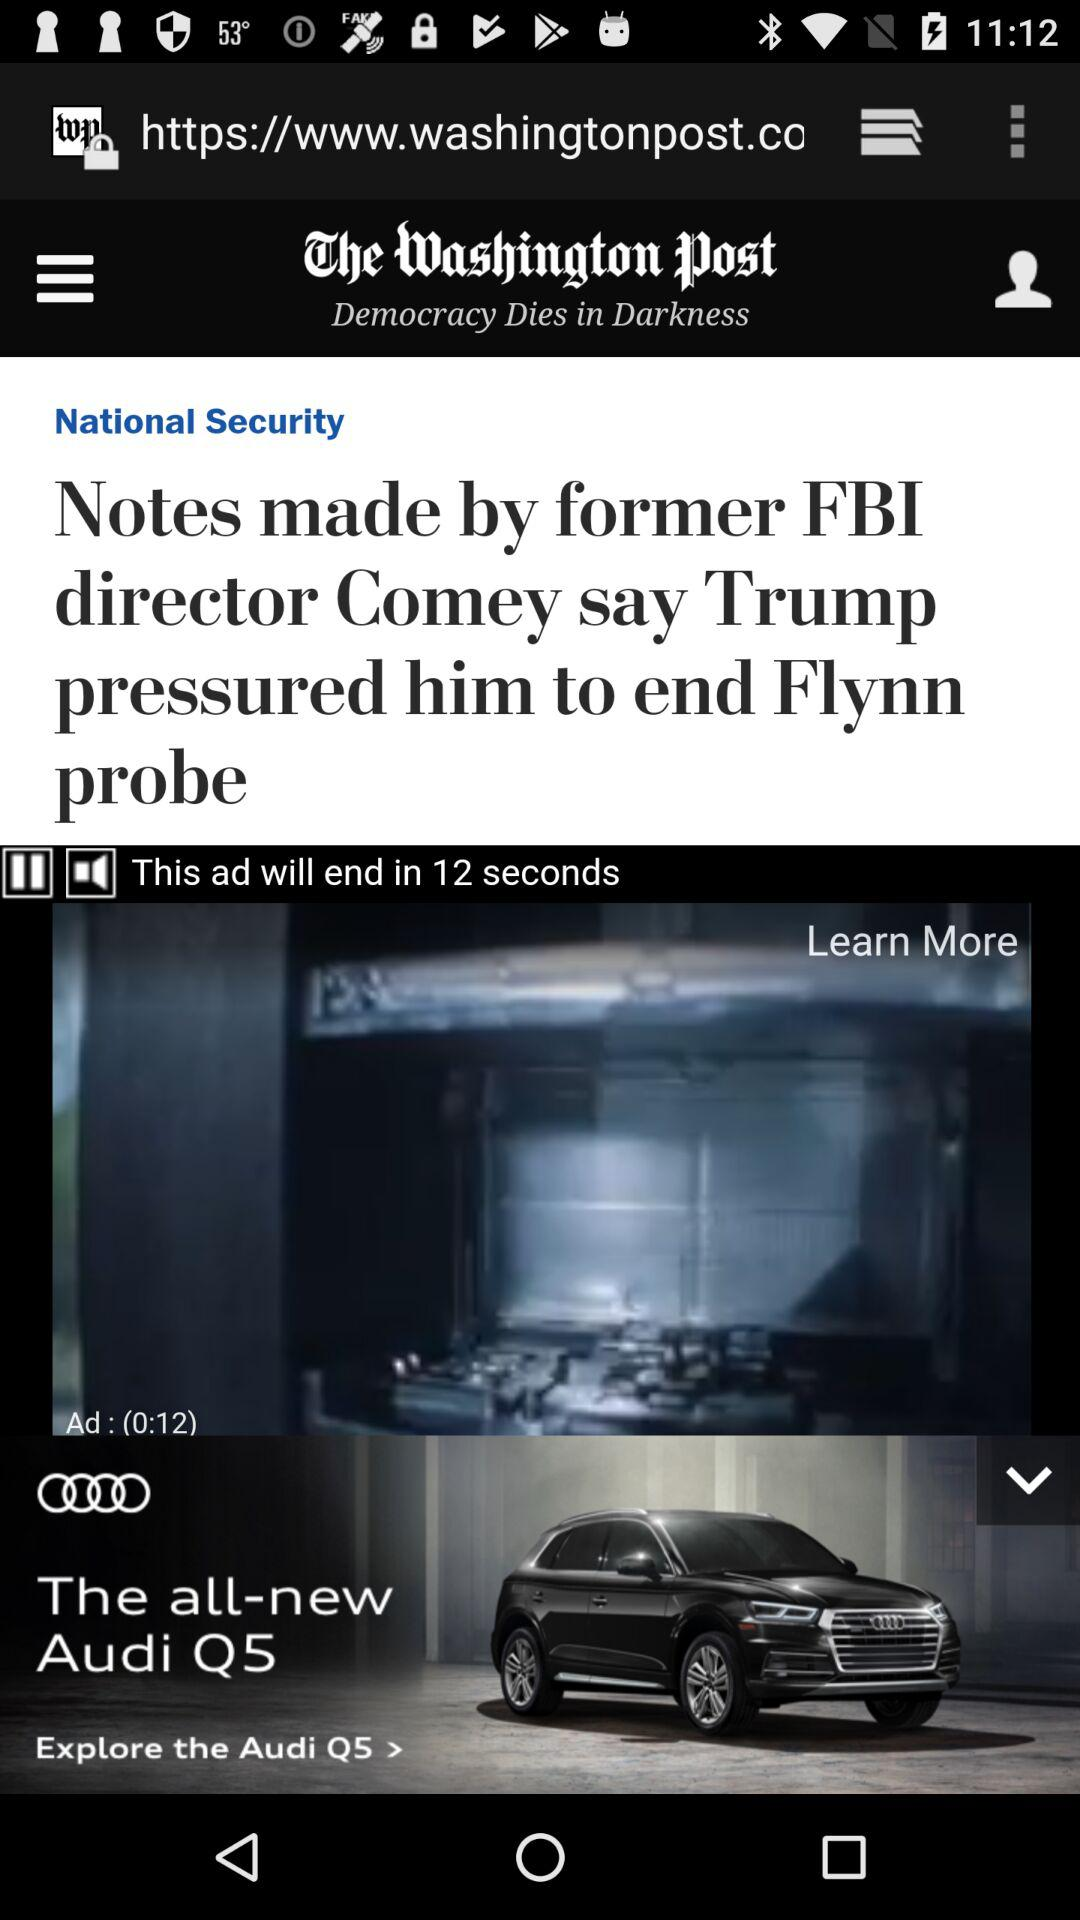How many more seconds are left in the ad?
Answer the question using a single word or phrase. 12 